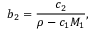Convert formula to latex. <formula><loc_0><loc_0><loc_500><loc_500>b _ { 2 } = { \frac { c _ { 2 } } { \rho - c _ { 1 } M _ { 1 } } } ,</formula> 